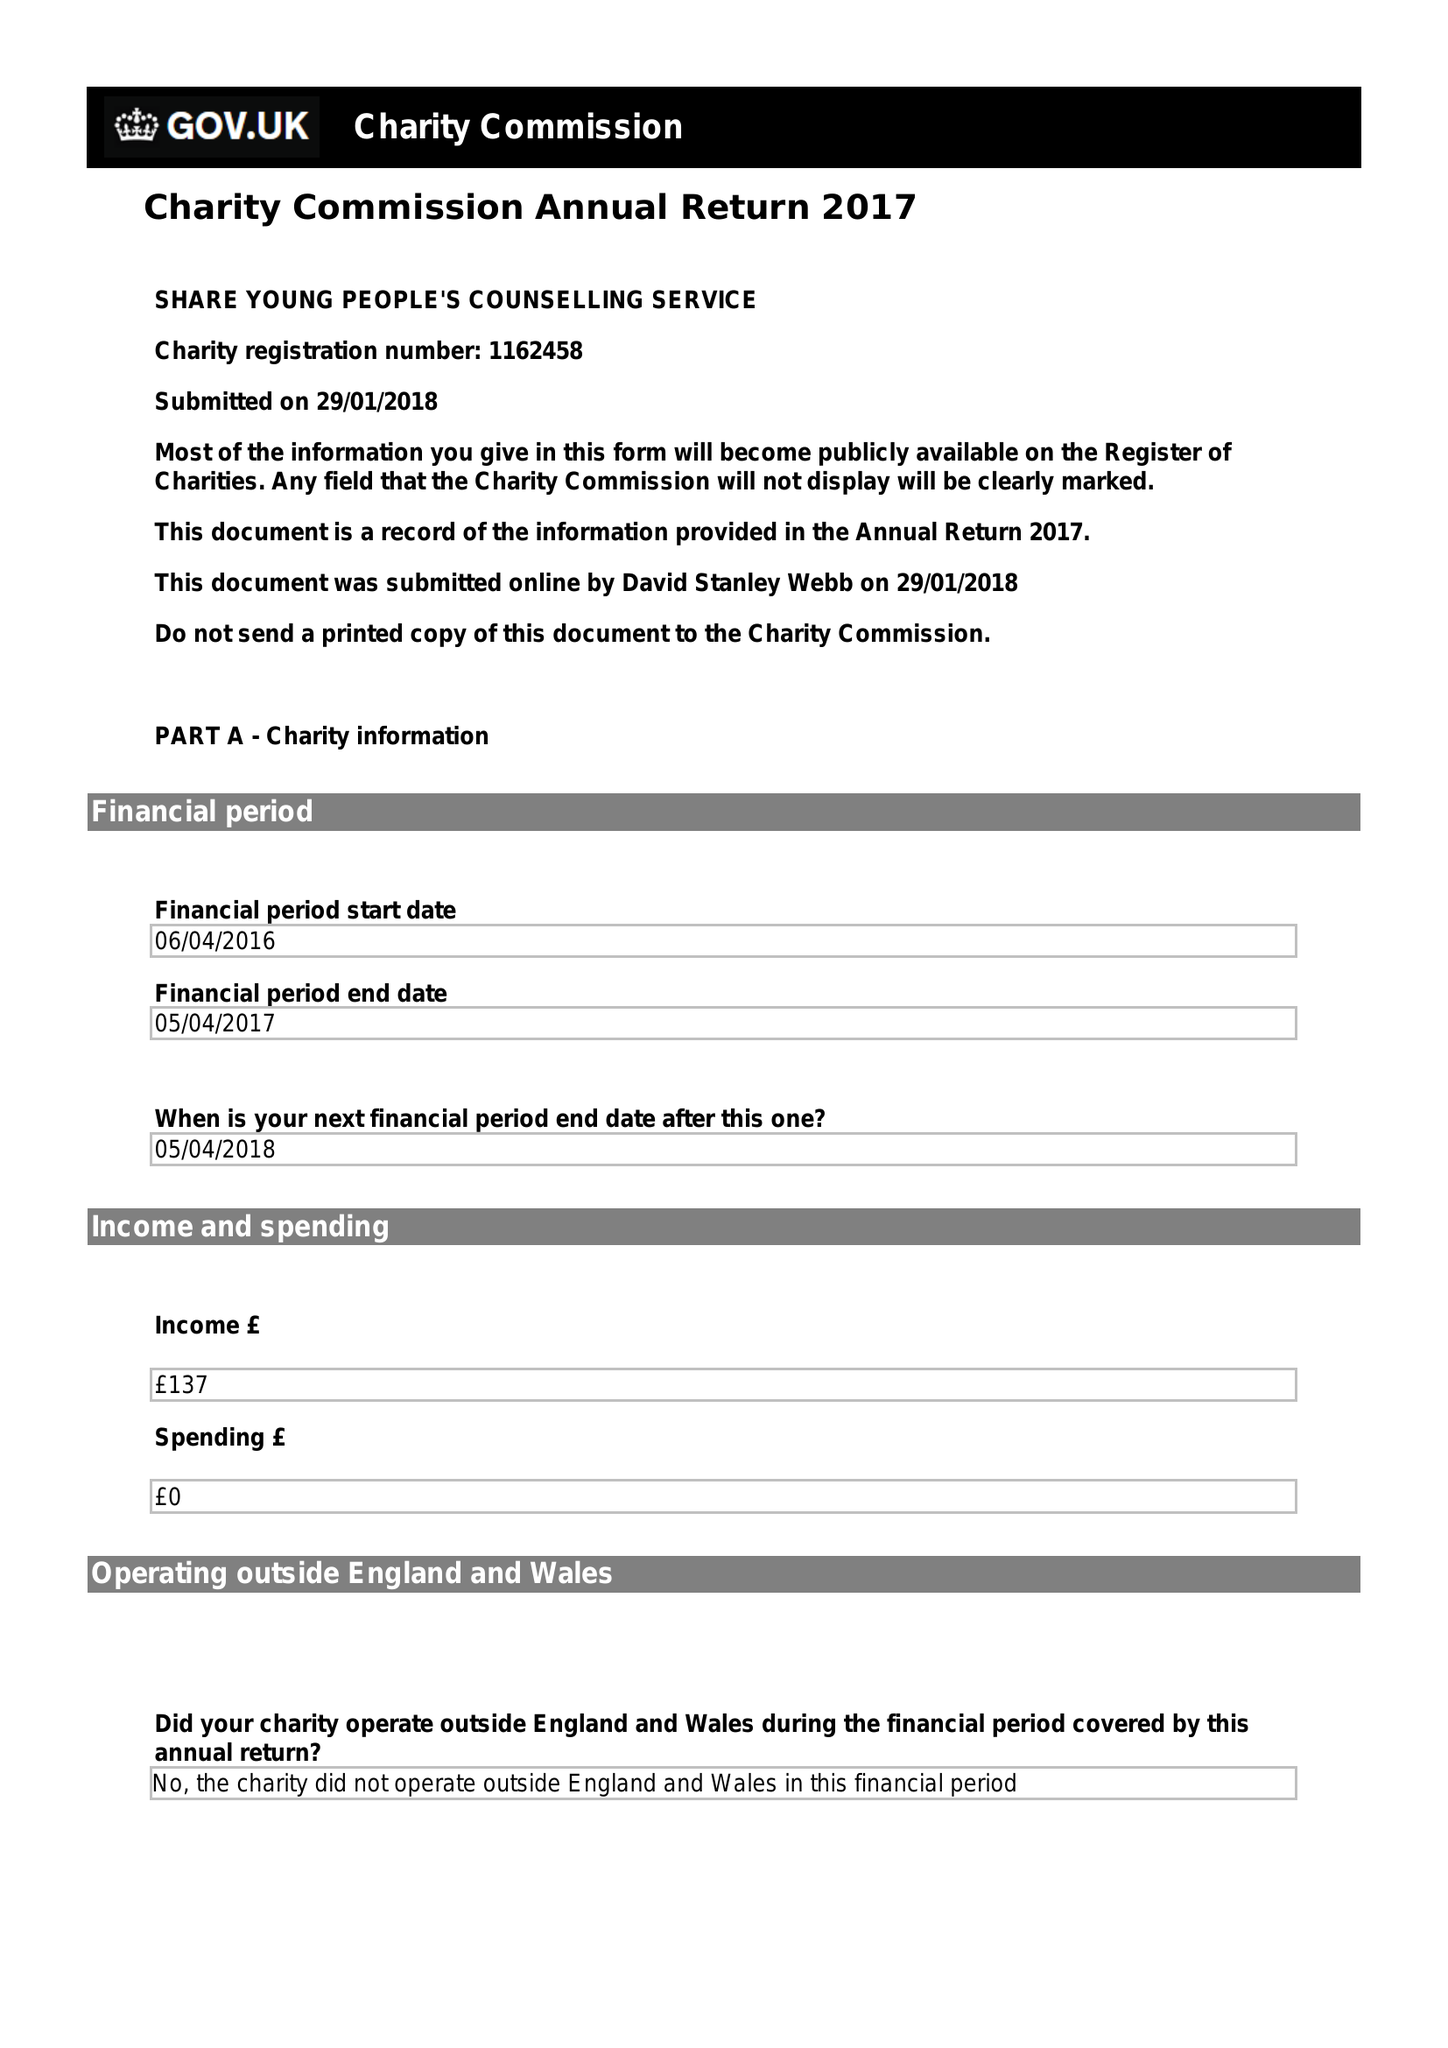What is the value for the income_annually_in_british_pounds?
Answer the question using a single word or phrase. 137.00 